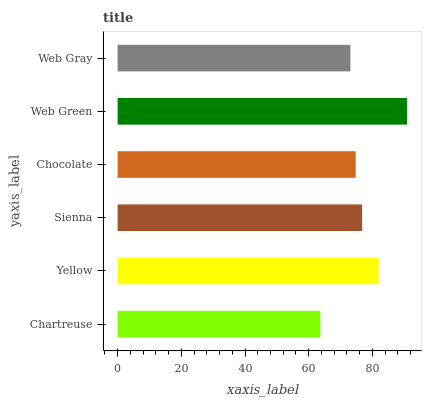Is Chartreuse the minimum?
Answer yes or no. Yes. Is Web Green the maximum?
Answer yes or no. Yes. Is Yellow the minimum?
Answer yes or no. No. Is Yellow the maximum?
Answer yes or no. No. Is Yellow greater than Chartreuse?
Answer yes or no. Yes. Is Chartreuse less than Yellow?
Answer yes or no. Yes. Is Chartreuse greater than Yellow?
Answer yes or no. No. Is Yellow less than Chartreuse?
Answer yes or no. No. Is Sienna the high median?
Answer yes or no. Yes. Is Chocolate the low median?
Answer yes or no. Yes. Is Web Green the high median?
Answer yes or no. No. Is Web Green the low median?
Answer yes or no. No. 